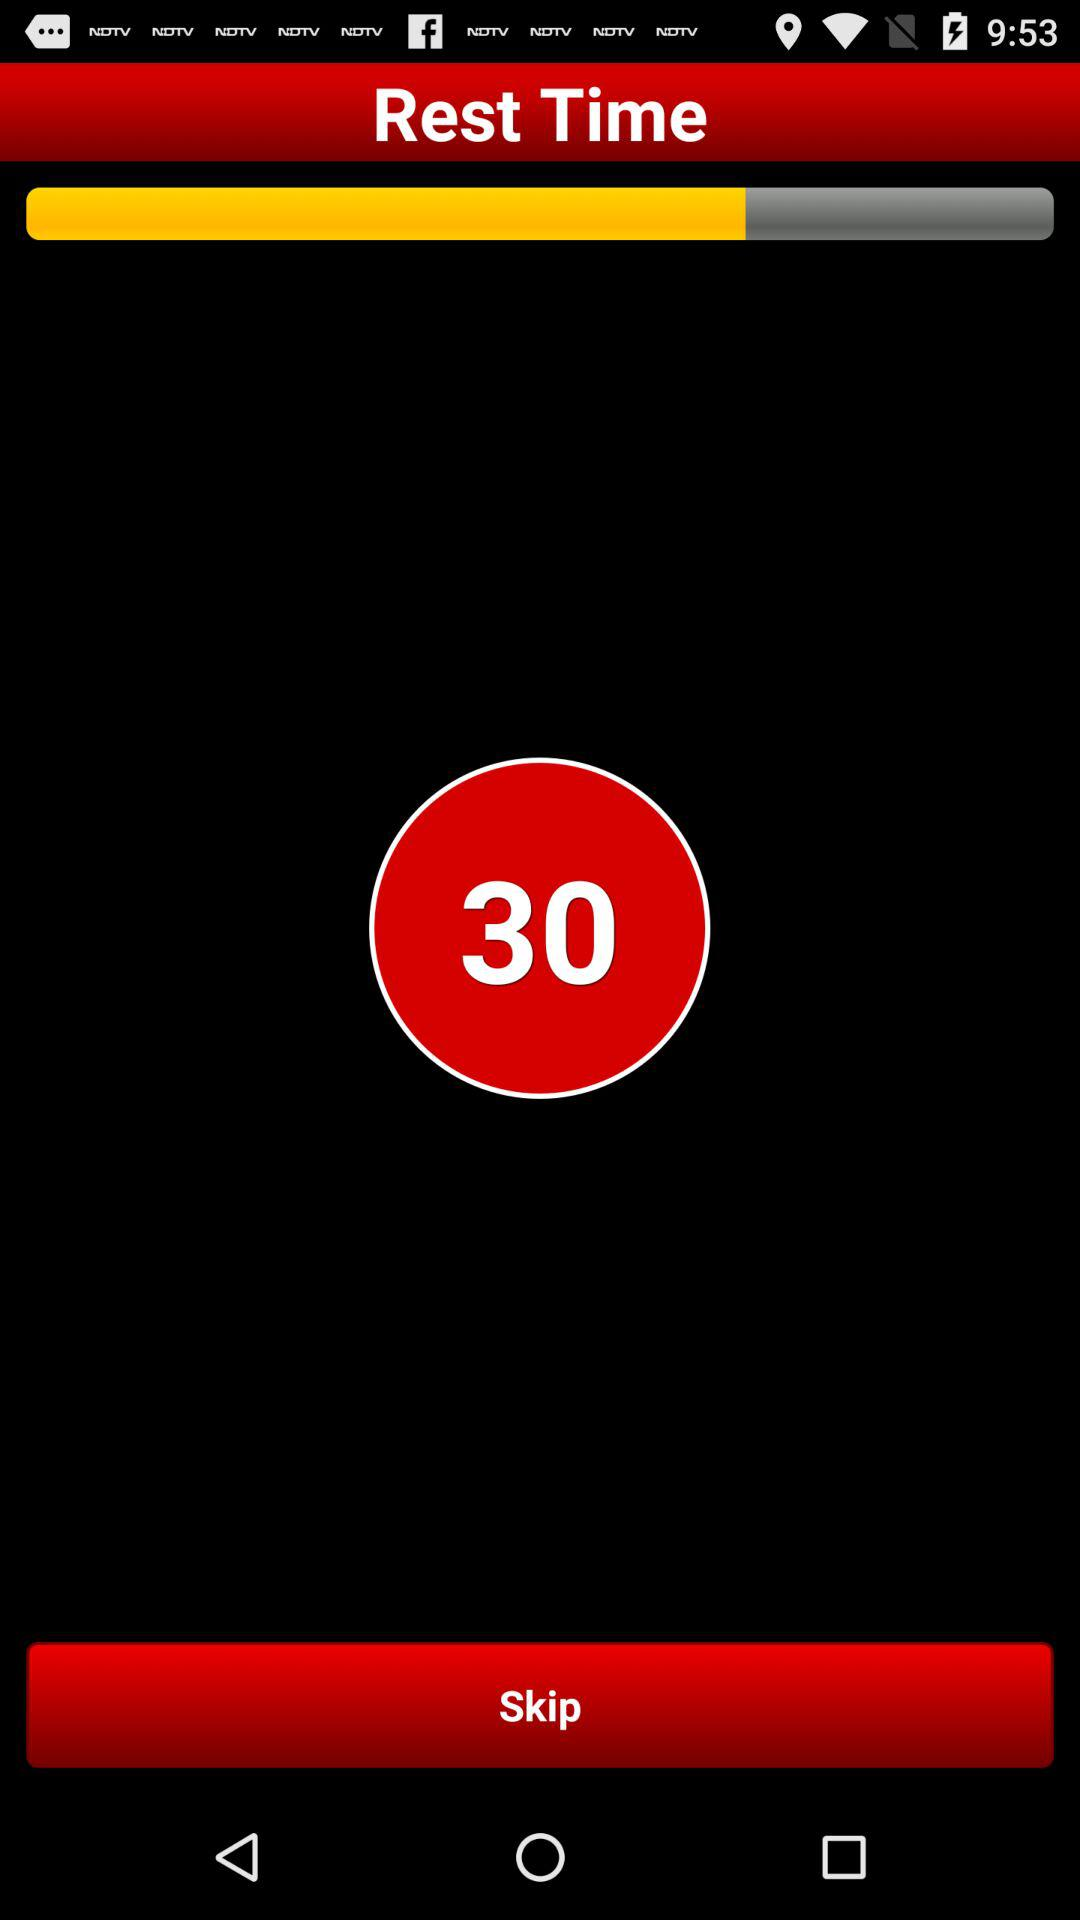What is the rest time? The rest time is 30. 